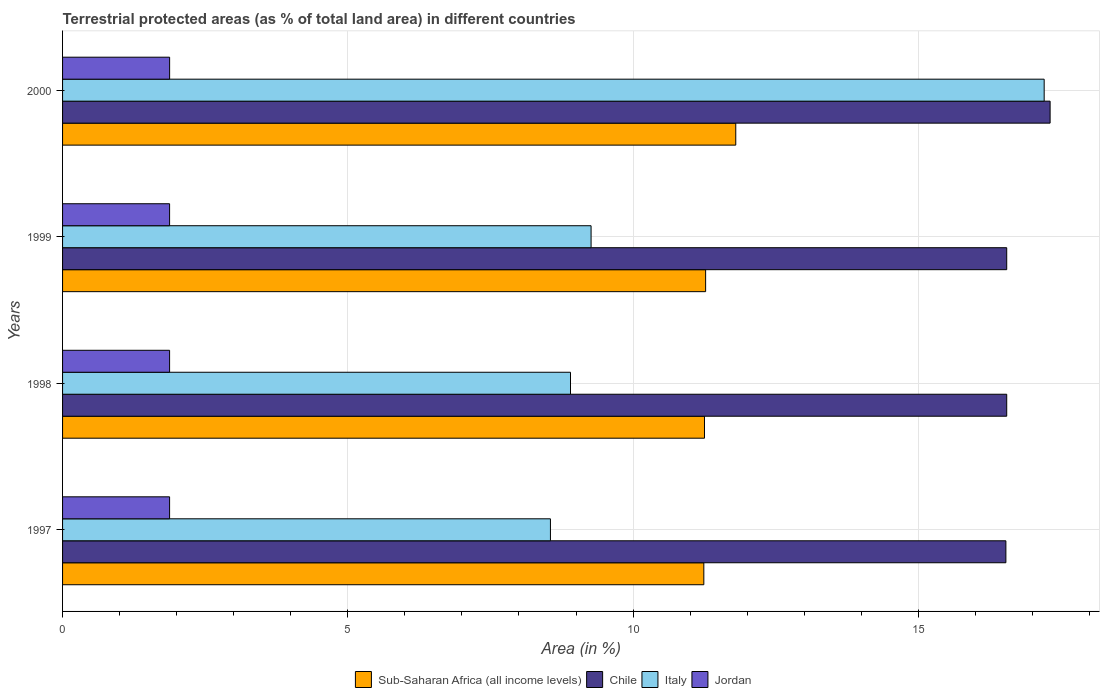How many groups of bars are there?
Provide a short and direct response. 4. What is the percentage of terrestrial protected land in Chile in 1999?
Offer a terse response. 16.55. Across all years, what is the maximum percentage of terrestrial protected land in Jordan?
Keep it short and to the point. 1.88. Across all years, what is the minimum percentage of terrestrial protected land in Sub-Saharan Africa (all income levels)?
Ensure brevity in your answer.  11.24. In which year was the percentage of terrestrial protected land in Italy minimum?
Offer a terse response. 1997. What is the total percentage of terrestrial protected land in Jordan in the graph?
Provide a succinct answer. 7.51. What is the difference between the percentage of terrestrial protected land in Sub-Saharan Africa (all income levels) in 1998 and that in 1999?
Provide a succinct answer. -0.02. What is the difference between the percentage of terrestrial protected land in Sub-Saharan Africa (all income levels) in 1997 and the percentage of terrestrial protected land in Chile in 1999?
Offer a very short reply. -5.31. What is the average percentage of terrestrial protected land in Jordan per year?
Your response must be concise. 1.88. In the year 1999, what is the difference between the percentage of terrestrial protected land in Chile and percentage of terrestrial protected land in Jordan?
Your answer should be very brief. 14.67. What is the ratio of the percentage of terrestrial protected land in Italy in 1998 to that in 1999?
Your answer should be compact. 0.96. What is the difference between the highest and the second highest percentage of terrestrial protected land in Jordan?
Give a very brief answer. 0. What is the difference between the highest and the lowest percentage of terrestrial protected land in Jordan?
Give a very brief answer. 0. What does the 1st bar from the top in 1999 represents?
Your answer should be compact. Jordan. How many bars are there?
Ensure brevity in your answer.  16. Are the values on the major ticks of X-axis written in scientific E-notation?
Provide a short and direct response. No. How are the legend labels stacked?
Ensure brevity in your answer.  Horizontal. What is the title of the graph?
Give a very brief answer. Terrestrial protected areas (as % of total land area) in different countries. What is the label or title of the X-axis?
Your response must be concise. Area (in %). What is the Area (in %) of Sub-Saharan Africa (all income levels) in 1997?
Offer a terse response. 11.24. What is the Area (in %) in Chile in 1997?
Your answer should be very brief. 16.54. What is the Area (in %) of Italy in 1997?
Offer a very short reply. 8.55. What is the Area (in %) in Jordan in 1997?
Keep it short and to the point. 1.88. What is the Area (in %) of Sub-Saharan Africa (all income levels) in 1998?
Ensure brevity in your answer.  11.25. What is the Area (in %) of Chile in 1998?
Give a very brief answer. 16.55. What is the Area (in %) of Italy in 1998?
Your answer should be very brief. 8.9. What is the Area (in %) in Jordan in 1998?
Keep it short and to the point. 1.88. What is the Area (in %) of Sub-Saharan Africa (all income levels) in 1999?
Your answer should be compact. 11.27. What is the Area (in %) of Chile in 1999?
Your answer should be compact. 16.55. What is the Area (in %) of Italy in 1999?
Ensure brevity in your answer.  9.26. What is the Area (in %) of Jordan in 1999?
Offer a terse response. 1.88. What is the Area (in %) of Sub-Saharan Africa (all income levels) in 2000?
Provide a short and direct response. 11.8. What is the Area (in %) of Chile in 2000?
Offer a terse response. 17.31. What is the Area (in %) of Italy in 2000?
Your response must be concise. 17.21. What is the Area (in %) in Jordan in 2000?
Offer a very short reply. 1.88. Across all years, what is the maximum Area (in %) of Sub-Saharan Africa (all income levels)?
Keep it short and to the point. 11.8. Across all years, what is the maximum Area (in %) of Chile?
Your answer should be very brief. 17.31. Across all years, what is the maximum Area (in %) of Italy?
Keep it short and to the point. 17.21. Across all years, what is the maximum Area (in %) of Jordan?
Your response must be concise. 1.88. Across all years, what is the minimum Area (in %) of Sub-Saharan Africa (all income levels)?
Your response must be concise. 11.24. Across all years, what is the minimum Area (in %) of Chile?
Your answer should be compact. 16.54. Across all years, what is the minimum Area (in %) in Italy?
Ensure brevity in your answer.  8.55. Across all years, what is the minimum Area (in %) of Jordan?
Make the answer very short. 1.88. What is the total Area (in %) in Sub-Saharan Africa (all income levels) in the graph?
Provide a short and direct response. 45.57. What is the total Area (in %) of Chile in the graph?
Provide a succinct answer. 66.95. What is the total Area (in %) of Italy in the graph?
Keep it short and to the point. 43.93. What is the total Area (in %) in Jordan in the graph?
Offer a very short reply. 7.51. What is the difference between the Area (in %) of Sub-Saharan Africa (all income levels) in 1997 and that in 1998?
Provide a short and direct response. -0.01. What is the difference between the Area (in %) of Chile in 1997 and that in 1998?
Provide a succinct answer. -0.01. What is the difference between the Area (in %) in Italy in 1997 and that in 1998?
Provide a succinct answer. -0.35. What is the difference between the Area (in %) in Jordan in 1997 and that in 1998?
Provide a short and direct response. 0. What is the difference between the Area (in %) of Sub-Saharan Africa (all income levels) in 1997 and that in 1999?
Ensure brevity in your answer.  -0.03. What is the difference between the Area (in %) of Chile in 1997 and that in 1999?
Provide a short and direct response. -0.01. What is the difference between the Area (in %) of Italy in 1997 and that in 1999?
Your answer should be very brief. -0.71. What is the difference between the Area (in %) in Jordan in 1997 and that in 1999?
Make the answer very short. 0. What is the difference between the Area (in %) in Sub-Saharan Africa (all income levels) in 1997 and that in 2000?
Offer a very short reply. -0.56. What is the difference between the Area (in %) of Chile in 1997 and that in 2000?
Make the answer very short. -0.78. What is the difference between the Area (in %) in Italy in 1997 and that in 2000?
Keep it short and to the point. -8.65. What is the difference between the Area (in %) in Jordan in 1997 and that in 2000?
Give a very brief answer. -0. What is the difference between the Area (in %) in Sub-Saharan Africa (all income levels) in 1998 and that in 1999?
Provide a short and direct response. -0.02. What is the difference between the Area (in %) of Italy in 1998 and that in 1999?
Offer a terse response. -0.36. What is the difference between the Area (in %) of Jordan in 1998 and that in 1999?
Your answer should be compact. 0. What is the difference between the Area (in %) of Sub-Saharan Africa (all income levels) in 1998 and that in 2000?
Your answer should be very brief. -0.55. What is the difference between the Area (in %) of Chile in 1998 and that in 2000?
Keep it short and to the point. -0.76. What is the difference between the Area (in %) in Italy in 1998 and that in 2000?
Keep it short and to the point. -8.3. What is the difference between the Area (in %) in Jordan in 1998 and that in 2000?
Your answer should be compact. -0. What is the difference between the Area (in %) of Sub-Saharan Africa (all income levels) in 1999 and that in 2000?
Make the answer very short. -0.53. What is the difference between the Area (in %) in Chile in 1999 and that in 2000?
Offer a very short reply. -0.76. What is the difference between the Area (in %) in Italy in 1999 and that in 2000?
Offer a terse response. -7.94. What is the difference between the Area (in %) of Jordan in 1999 and that in 2000?
Provide a succinct answer. -0. What is the difference between the Area (in %) in Sub-Saharan Africa (all income levels) in 1997 and the Area (in %) in Chile in 1998?
Make the answer very short. -5.31. What is the difference between the Area (in %) in Sub-Saharan Africa (all income levels) in 1997 and the Area (in %) in Italy in 1998?
Your answer should be compact. 2.34. What is the difference between the Area (in %) of Sub-Saharan Africa (all income levels) in 1997 and the Area (in %) of Jordan in 1998?
Your answer should be very brief. 9.36. What is the difference between the Area (in %) of Chile in 1997 and the Area (in %) of Italy in 1998?
Your response must be concise. 7.63. What is the difference between the Area (in %) of Chile in 1997 and the Area (in %) of Jordan in 1998?
Ensure brevity in your answer.  14.66. What is the difference between the Area (in %) in Italy in 1997 and the Area (in %) in Jordan in 1998?
Give a very brief answer. 6.68. What is the difference between the Area (in %) in Sub-Saharan Africa (all income levels) in 1997 and the Area (in %) in Chile in 1999?
Your response must be concise. -5.31. What is the difference between the Area (in %) of Sub-Saharan Africa (all income levels) in 1997 and the Area (in %) of Italy in 1999?
Your answer should be compact. 1.98. What is the difference between the Area (in %) in Sub-Saharan Africa (all income levels) in 1997 and the Area (in %) in Jordan in 1999?
Ensure brevity in your answer.  9.36. What is the difference between the Area (in %) of Chile in 1997 and the Area (in %) of Italy in 1999?
Keep it short and to the point. 7.27. What is the difference between the Area (in %) of Chile in 1997 and the Area (in %) of Jordan in 1999?
Provide a short and direct response. 14.66. What is the difference between the Area (in %) in Italy in 1997 and the Area (in %) in Jordan in 1999?
Keep it short and to the point. 6.68. What is the difference between the Area (in %) of Sub-Saharan Africa (all income levels) in 1997 and the Area (in %) of Chile in 2000?
Ensure brevity in your answer.  -6.07. What is the difference between the Area (in %) in Sub-Saharan Africa (all income levels) in 1997 and the Area (in %) in Italy in 2000?
Offer a very short reply. -5.97. What is the difference between the Area (in %) of Sub-Saharan Africa (all income levels) in 1997 and the Area (in %) of Jordan in 2000?
Your answer should be very brief. 9.36. What is the difference between the Area (in %) of Chile in 1997 and the Area (in %) of Italy in 2000?
Offer a terse response. -0.67. What is the difference between the Area (in %) in Chile in 1997 and the Area (in %) in Jordan in 2000?
Provide a succinct answer. 14.66. What is the difference between the Area (in %) in Italy in 1997 and the Area (in %) in Jordan in 2000?
Make the answer very short. 6.68. What is the difference between the Area (in %) of Sub-Saharan Africa (all income levels) in 1998 and the Area (in %) of Chile in 1999?
Provide a short and direct response. -5.3. What is the difference between the Area (in %) of Sub-Saharan Africa (all income levels) in 1998 and the Area (in %) of Italy in 1999?
Make the answer very short. 1.99. What is the difference between the Area (in %) in Sub-Saharan Africa (all income levels) in 1998 and the Area (in %) in Jordan in 1999?
Ensure brevity in your answer.  9.38. What is the difference between the Area (in %) of Chile in 1998 and the Area (in %) of Italy in 1999?
Make the answer very short. 7.29. What is the difference between the Area (in %) of Chile in 1998 and the Area (in %) of Jordan in 1999?
Ensure brevity in your answer.  14.67. What is the difference between the Area (in %) of Italy in 1998 and the Area (in %) of Jordan in 1999?
Provide a short and direct response. 7.03. What is the difference between the Area (in %) in Sub-Saharan Africa (all income levels) in 1998 and the Area (in %) in Chile in 2000?
Your response must be concise. -6.06. What is the difference between the Area (in %) of Sub-Saharan Africa (all income levels) in 1998 and the Area (in %) of Italy in 2000?
Provide a succinct answer. -5.95. What is the difference between the Area (in %) in Sub-Saharan Africa (all income levels) in 1998 and the Area (in %) in Jordan in 2000?
Provide a succinct answer. 9.38. What is the difference between the Area (in %) of Chile in 1998 and the Area (in %) of Italy in 2000?
Your answer should be compact. -0.66. What is the difference between the Area (in %) of Chile in 1998 and the Area (in %) of Jordan in 2000?
Your answer should be very brief. 14.67. What is the difference between the Area (in %) in Italy in 1998 and the Area (in %) in Jordan in 2000?
Ensure brevity in your answer.  7.03. What is the difference between the Area (in %) in Sub-Saharan Africa (all income levels) in 1999 and the Area (in %) in Chile in 2000?
Your answer should be compact. -6.04. What is the difference between the Area (in %) in Sub-Saharan Africa (all income levels) in 1999 and the Area (in %) in Italy in 2000?
Your response must be concise. -5.93. What is the difference between the Area (in %) of Sub-Saharan Africa (all income levels) in 1999 and the Area (in %) of Jordan in 2000?
Ensure brevity in your answer.  9.4. What is the difference between the Area (in %) in Chile in 1999 and the Area (in %) in Italy in 2000?
Your answer should be compact. -0.66. What is the difference between the Area (in %) in Chile in 1999 and the Area (in %) in Jordan in 2000?
Your response must be concise. 14.67. What is the difference between the Area (in %) in Italy in 1999 and the Area (in %) in Jordan in 2000?
Provide a short and direct response. 7.39. What is the average Area (in %) in Sub-Saharan Africa (all income levels) per year?
Offer a terse response. 11.39. What is the average Area (in %) of Chile per year?
Keep it short and to the point. 16.74. What is the average Area (in %) of Italy per year?
Your answer should be compact. 10.98. What is the average Area (in %) in Jordan per year?
Keep it short and to the point. 1.88. In the year 1997, what is the difference between the Area (in %) in Sub-Saharan Africa (all income levels) and Area (in %) in Chile?
Offer a very short reply. -5.29. In the year 1997, what is the difference between the Area (in %) of Sub-Saharan Africa (all income levels) and Area (in %) of Italy?
Give a very brief answer. 2.69. In the year 1997, what is the difference between the Area (in %) of Sub-Saharan Africa (all income levels) and Area (in %) of Jordan?
Provide a short and direct response. 9.36. In the year 1997, what is the difference between the Area (in %) in Chile and Area (in %) in Italy?
Offer a terse response. 7.98. In the year 1997, what is the difference between the Area (in %) of Chile and Area (in %) of Jordan?
Provide a short and direct response. 14.66. In the year 1997, what is the difference between the Area (in %) in Italy and Area (in %) in Jordan?
Your answer should be very brief. 6.68. In the year 1998, what is the difference between the Area (in %) in Sub-Saharan Africa (all income levels) and Area (in %) in Chile?
Your answer should be compact. -5.3. In the year 1998, what is the difference between the Area (in %) in Sub-Saharan Africa (all income levels) and Area (in %) in Italy?
Offer a very short reply. 2.35. In the year 1998, what is the difference between the Area (in %) of Sub-Saharan Africa (all income levels) and Area (in %) of Jordan?
Ensure brevity in your answer.  9.38. In the year 1998, what is the difference between the Area (in %) of Chile and Area (in %) of Italy?
Make the answer very short. 7.65. In the year 1998, what is the difference between the Area (in %) in Chile and Area (in %) in Jordan?
Provide a succinct answer. 14.67. In the year 1998, what is the difference between the Area (in %) of Italy and Area (in %) of Jordan?
Give a very brief answer. 7.03. In the year 1999, what is the difference between the Area (in %) in Sub-Saharan Africa (all income levels) and Area (in %) in Chile?
Ensure brevity in your answer.  -5.28. In the year 1999, what is the difference between the Area (in %) of Sub-Saharan Africa (all income levels) and Area (in %) of Italy?
Your answer should be very brief. 2.01. In the year 1999, what is the difference between the Area (in %) of Sub-Saharan Africa (all income levels) and Area (in %) of Jordan?
Give a very brief answer. 9.4. In the year 1999, what is the difference between the Area (in %) of Chile and Area (in %) of Italy?
Provide a short and direct response. 7.29. In the year 1999, what is the difference between the Area (in %) in Chile and Area (in %) in Jordan?
Keep it short and to the point. 14.67. In the year 1999, what is the difference between the Area (in %) in Italy and Area (in %) in Jordan?
Ensure brevity in your answer.  7.39. In the year 2000, what is the difference between the Area (in %) of Sub-Saharan Africa (all income levels) and Area (in %) of Chile?
Provide a succinct answer. -5.51. In the year 2000, what is the difference between the Area (in %) of Sub-Saharan Africa (all income levels) and Area (in %) of Italy?
Provide a succinct answer. -5.41. In the year 2000, what is the difference between the Area (in %) in Sub-Saharan Africa (all income levels) and Area (in %) in Jordan?
Your answer should be compact. 9.92. In the year 2000, what is the difference between the Area (in %) of Chile and Area (in %) of Italy?
Keep it short and to the point. 0.1. In the year 2000, what is the difference between the Area (in %) in Chile and Area (in %) in Jordan?
Give a very brief answer. 15.43. In the year 2000, what is the difference between the Area (in %) in Italy and Area (in %) in Jordan?
Provide a succinct answer. 15.33. What is the ratio of the Area (in %) of Chile in 1997 to that in 1998?
Your response must be concise. 1. What is the ratio of the Area (in %) of Italy in 1997 to that in 1998?
Make the answer very short. 0.96. What is the ratio of the Area (in %) of Sub-Saharan Africa (all income levels) in 1997 to that in 1999?
Your answer should be very brief. 1. What is the ratio of the Area (in %) in Chile in 1997 to that in 1999?
Your answer should be very brief. 1. What is the ratio of the Area (in %) in Jordan in 1997 to that in 1999?
Ensure brevity in your answer.  1. What is the ratio of the Area (in %) in Sub-Saharan Africa (all income levels) in 1997 to that in 2000?
Offer a very short reply. 0.95. What is the ratio of the Area (in %) of Chile in 1997 to that in 2000?
Give a very brief answer. 0.96. What is the ratio of the Area (in %) in Italy in 1997 to that in 2000?
Provide a succinct answer. 0.5. What is the ratio of the Area (in %) of Jordan in 1997 to that in 2000?
Offer a very short reply. 1. What is the ratio of the Area (in %) of Chile in 1998 to that in 1999?
Keep it short and to the point. 1. What is the ratio of the Area (in %) of Italy in 1998 to that in 1999?
Offer a terse response. 0.96. What is the ratio of the Area (in %) of Jordan in 1998 to that in 1999?
Offer a very short reply. 1. What is the ratio of the Area (in %) in Sub-Saharan Africa (all income levels) in 1998 to that in 2000?
Keep it short and to the point. 0.95. What is the ratio of the Area (in %) of Chile in 1998 to that in 2000?
Offer a terse response. 0.96. What is the ratio of the Area (in %) of Italy in 1998 to that in 2000?
Your answer should be very brief. 0.52. What is the ratio of the Area (in %) of Jordan in 1998 to that in 2000?
Your response must be concise. 1. What is the ratio of the Area (in %) in Sub-Saharan Africa (all income levels) in 1999 to that in 2000?
Your answer should be compact. 0.96. What is the ratio of the Area (in %) in Chile in 1999 to that in 2000?
Ensure brevity in your answer.  0.96. What is the ratio of the Area (in %) in Italy in 1999 to that in 2000?
Your answer should be compact. 0.54. What is the ratio of the Area (in %) in Jordan in 1999 to that in 2000?
Keep it short and to the point. 1. What is the difference between the highest and the second highest Area (in %) of Sub-Saharan Africa (all income levels)?
Keep it short and to the point. 0.53. What is the difference between the highest and the second highest Area (in %) in Chile?
Keep it short and to the point. 0.76. What is the difference between the highest and the second highest Area (in %) in Italy?
Provide a short and direct response. 7.94. What is the difference between the highest and the second highest Area (in %) of Jordan?
Provide a short and direct response. 0. What is the difference between the highest and the lowest Area (in %) in Sub-Saharan Africa (all income levels)?
Provide a succinct answer. 0.56. What is the difference between the highest and the lowest Area (in %) in Chile?
Offer a terse response. 0.78. What is the difference between the highest and the lowest Area (in %) in Italy?
Make the answer very short. 8.65. What is the difference between the highest and the lowest Area (in %) of Jordan?
Your response must be concise. 0. 